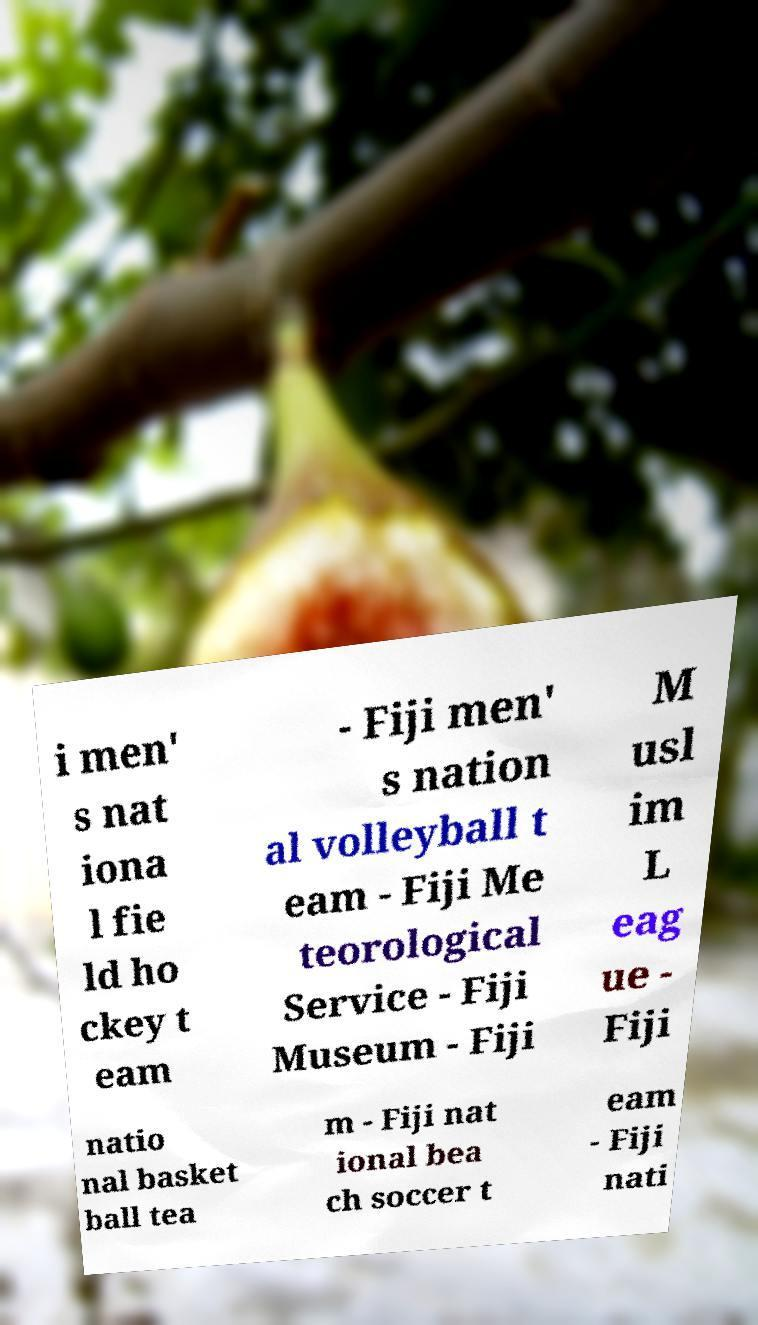Please read and relay the text visible in this image. What does it say? i men' s nat iona l fie ld ho ckey t eam - Fiji men' s nation al volleyball t eam - Fiji Me teorological Service - Fiji Museum - Fiji M usl im L eag ue - Fiji natio nal basket ball tea m - Fiji nat ional bea ch soccer t eam - Fiji nati 